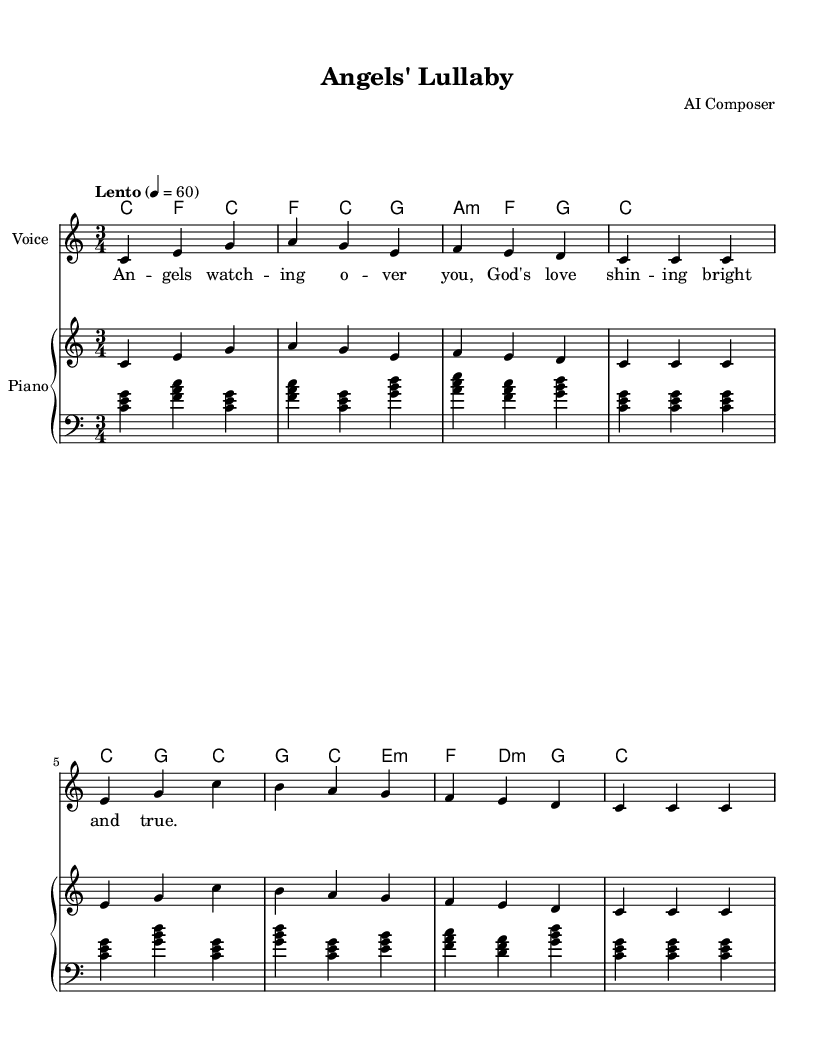What is the key signature of this music? The key signature is C major, which has no sharps or flats.
Answer: C major What is the time signature of this music? The time signature is indicated right after the clef sign, and it's 3/4, meaning there are three beats in each measure.
Answer: 3/4 What is the tempo marking of the music? The tempo marking is "Lento," and it is further specified with a metronome marking of 60, indicating a slow pace.
Answer: Lento How many measures are there in total? Counting the measures in the melody section, there are 8 measures in total present in the sheet music.
Answer: 8 What is the first note of the melody? The first note in the melody is a C note, which is located on the first line of the staff in the treble clef.
Answer: C What is the main theme of the lyrics provided? The lyrics express a comforting sentiment related to angels watching over, emphasizing God's love as the central theme, which is very typical in religious lullabies.
Answer: Angels watching over you What is the harmony accompanying the chorus section? The harmony indicates the chords played while the melody is sung, and it shows a progression typical for lullabies, starting with C major and alternating with F and G chords.
Answer: C, F, G 